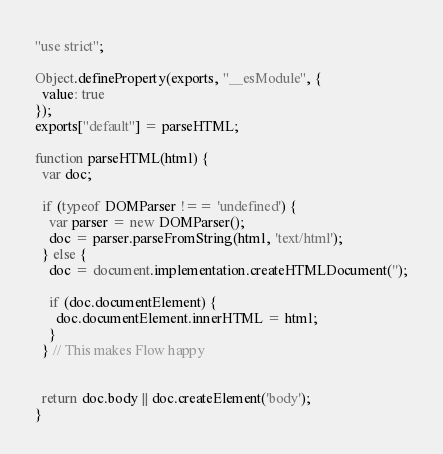<code> <loc_0><loc_0><loc_500><loc_500><_JavaScript_>"use strict";

Object.defineProperty(exports, "__esModule", {
  value: true
});
exports["default"] = parseHTML;

function parseHTML(html) {
  var doc;

  if (typeof DOMParser !== 'undefined') {
    var parser = new DOMParser();
    doc = parser.parseFromString(html, 'text/html');
  } else {
    doc = document.implementation.createHTMLDocument('');

    if (doc.documentElement) {
      doc.documentElement.innerHTML = html;
    }
  } // This makes Flow happy


  return doc.body || doc.createElement('body');
}</code> 